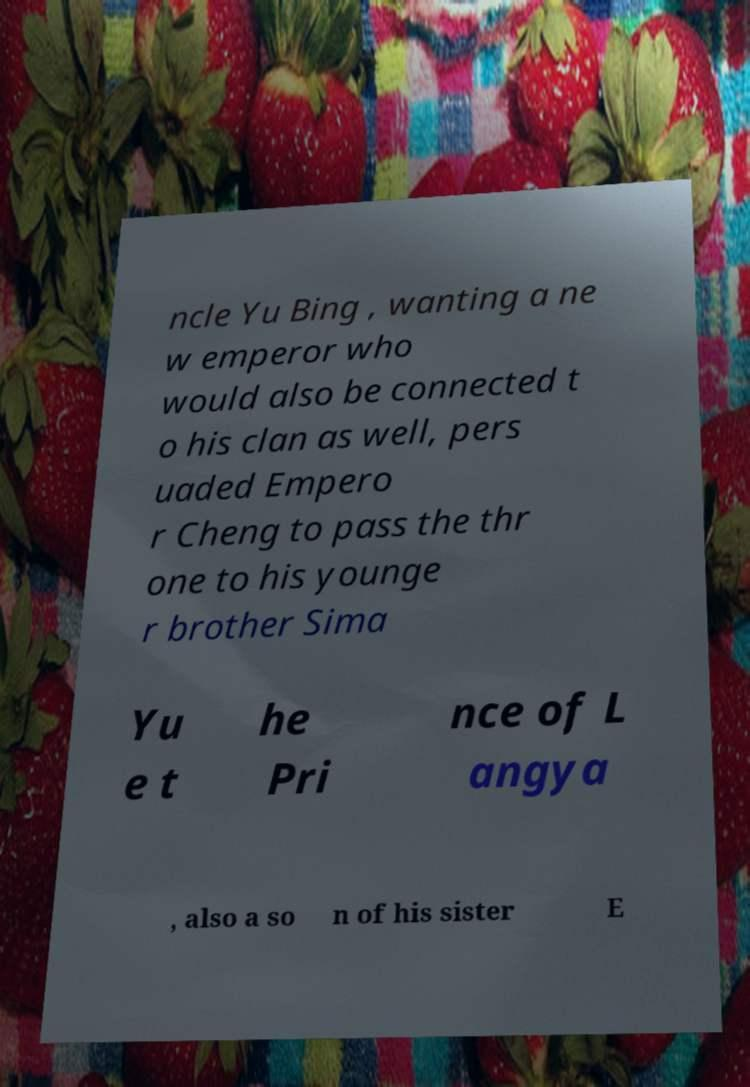For documentation purposes, I need the text within this image transcribed. Could you provide that? ncle Yu Bing , wanting a ne w emperor who would also be connected t o his clan as well, pers uaded Empero r Cheng to pass the thr one to his younge r brother Sima Yu e t he Pri nce of L angya , also a so n of his sister E 